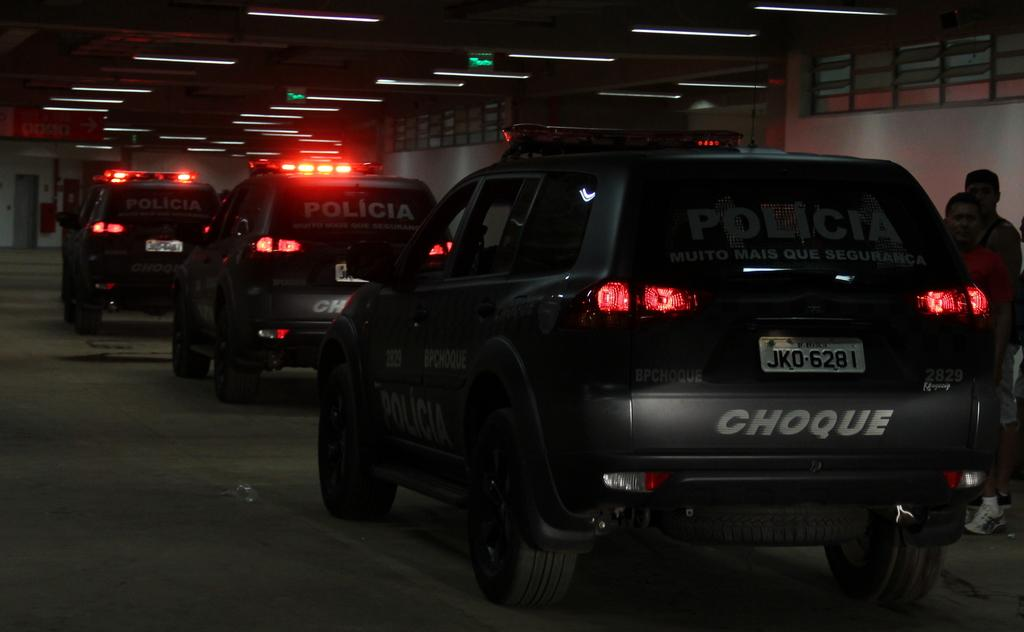Provide a one-sentence caption for the provided image. Several police vehicles that say Choque on the back drive through a tunnel. 